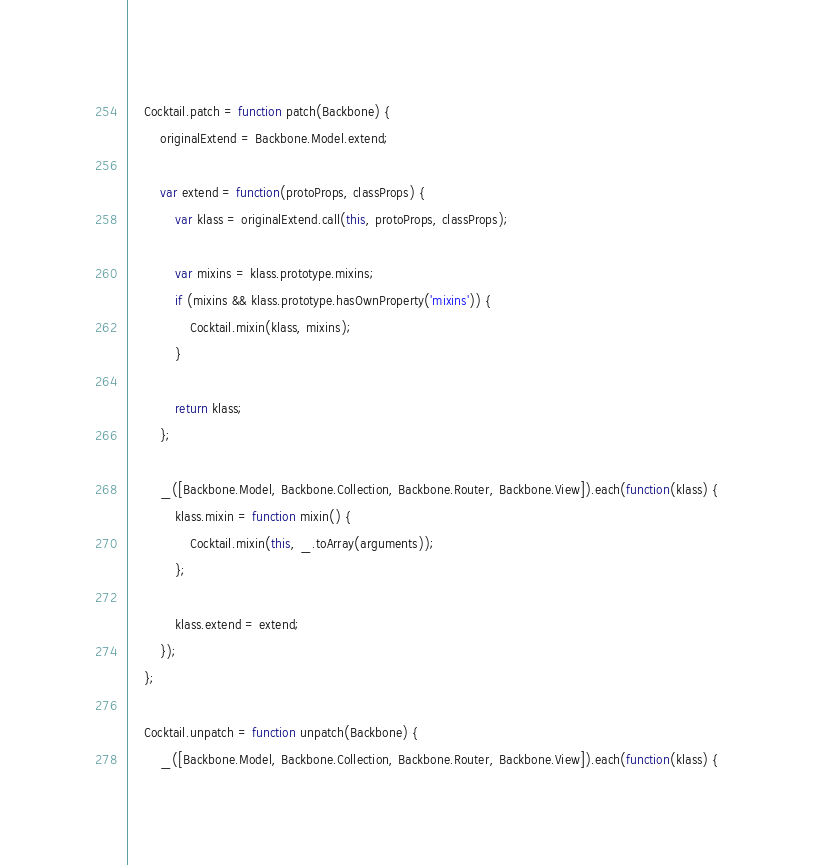<code> <loc_0><loc_0><loc_500><loc_500><_JavaScript_>
    Cocktail.patch = function patch(Backbone) {
        originalExtend = Backbone.Model.extend;

        var extend = function(protoProps, classProps) {
            var klass = originalExtend.call(this, protoProps, classProps);

            var mixins = klass.prototype.mixins;
            if (mixins && klass.prototype.hasOwnProperty('mixins')) {
                Cocktail.mixin(klass, mixins);
            }

            return klass;
        };

        _([Backbone.Model, Backbone.Collection, Backbone.Router, Backbone.View]).each(function(klass) {
            klass.mixin = function mixin() {
                Cocktail.mixin(this, _.toArray(arguments));
            };

            klass.extend = extend;
        });
    };

    Cocktail.unpatch = function unpatch(Backbone) {
        _([Backbone.Model, Backbone.Collection, Backbone.Router, Backbone.View]).each(function(klass) {</code> 